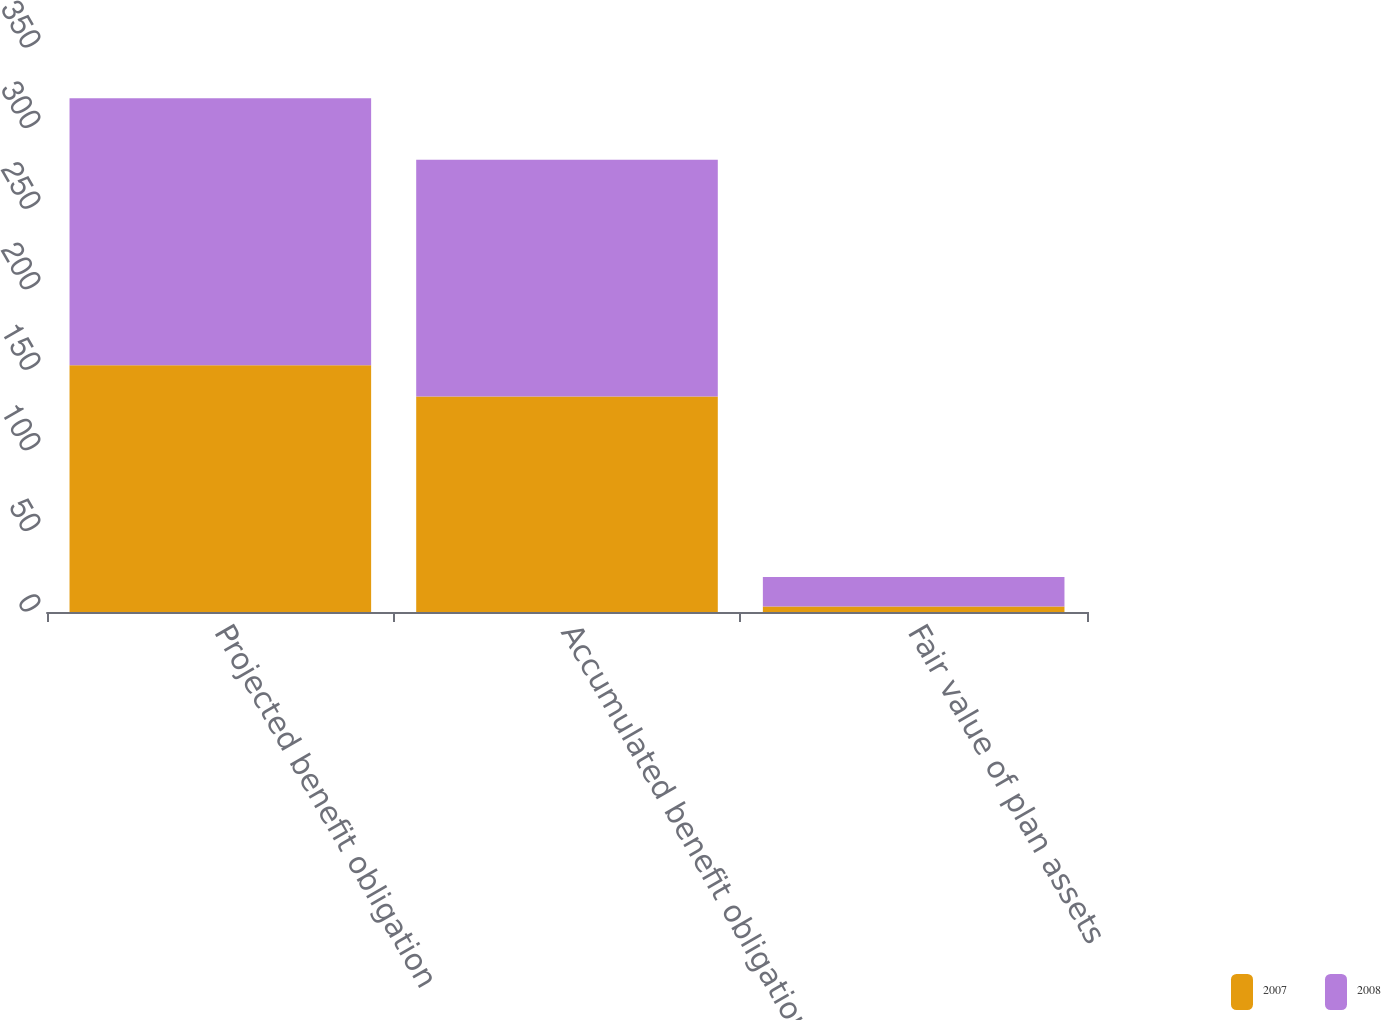Convert chart. <chart><loc_0><loc_0><loc_500><loc_500><stacked_bar_chart><ecel><fcel>Projected benefit obligation<fcel>Accumulated benefit obligation<fcel>Fair value of plan assets<nl><fcel>2007<fcel>153.1<fcel>133.8<fcel>3.4<nl><fcel>2008<fcel>165.7<fcel>146.8<fcel>18.3<nl></chart> 